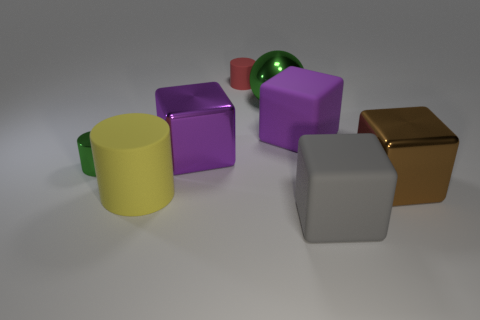Subtract all brown cubes. How many cubes are left? 3 Add 1 large cyan cylinders. How many objects exist? 9 Subtract all purple blocks. How many blocks are left? 2 Subtract 1 cubes. How many cubes are left? 3 Subtract all small gray metal things. Subtract all balls. How many objects are left? 7 Add 8 large metallic balls. How many large metallic balls are left? 9 Add 7 purple things. How many purple things exist? 9 Subtract 1 brown cubes. How many objects are left? 7 Subtract all cylinders. How many objects are left? 5 Subtract all brown cubes. Subtract all red cylinders. How many cubes are left? 3 